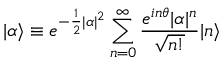Convert formula to latex. <formula><loc_0><loc_0><loc_500><loc_500>| \alpha \rangle \equiv e ^ { - \frac { 1 } { 2 } | \alpha | ^ { 2 } } \sum _ { n = 0 } ^ { \infty } \frac { e ^ { i n \theta } | \alpha | ^ { n } } { \sqrt { n ! } } | n \rangle</formula> 